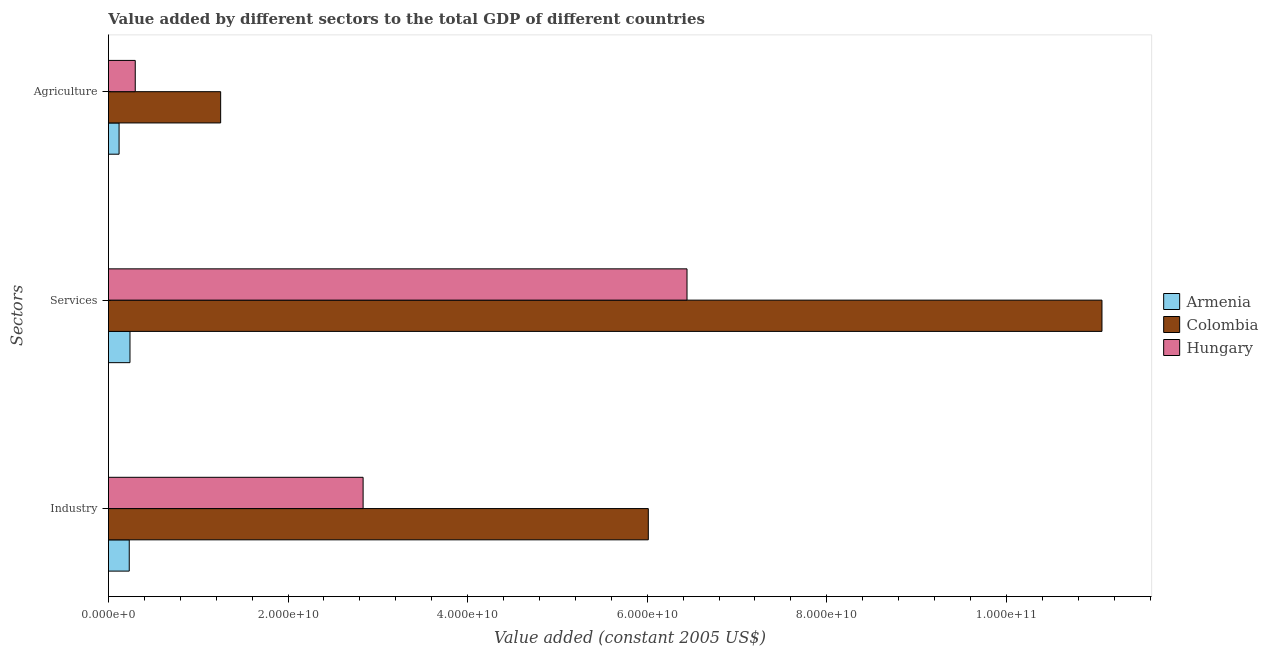Are the number of bars per tick equal to the number of legend labels?
Your answer should be compact. Yes. How many bars are there on the 1st tick from the top?
Offer a terse response. 3. How many bars are there on the 3rd tick from the bottom?
Your answer should be compact. 3. What is the label of the 3rd group of bars from the top?
Provide a succinct answer. Industry. What is the value added by services in Hungary?
Provide a short and direct response. 6.44e+1. Across all countries, what is the maximum value added by industrial sector?
Give a very brief answer. 6.01e+1. Across all countries, what is the minimum value added by industrial sector?
Give a very brief answer. 2.32e+09. In which country was the value added by industrial sector minimum?
Give a very brief answer. Armenia. What is the total value added by industrial sector in the graph?
Offer a terse response. 9.08e+1. What is the difference between the value added by agricultural sector in Armenia and that in Hungary?
Your answer should be compact. -1.80e+09. What is the difference between the value added by industrial sector in Hungary and the value added by services in Armenia?
Keep it short and to the point. 2.60e+1. What is the average value added by agricultural sector per country?
Your answer should be compact. 5.56e+09. What is the difference between the value added by industrial sector and value added by services in Colombia?
Offer a terse response. -5.05e+1. In how many countries, is the value added by agricultural sector greater than 32000000000 US$?
Give a very brief answer. 0. What is the ratio of the value added by agricultural sector in Colombia to that in Hungary?
Offer a terse response. 4.18. Is the value added by industrial sector in Armenia less than that in Hungary?
Offer a terse response. Yes. What is the difference between the highest and the second highest value added by agricultural sector?
Provide a succinct answer. 9.51e+09. What is the difference between the highest and the lowest value added by agricultural sector?
Offer a very short reply. 1.13e+1. Is the sum of the value added by industrial sector in Hungary and Colombia greater than the maximum value added by services across all countries?
Make the answer very short. No. What does the 3rd bar from the top in Industry represents?
Keep it short and to the point. Armenia. Is it the case that in every country, the sum of the value added by industrial sector and value added by services is greater than the value added by agricultural sector?
Your response must be concise. Yes. How many bars are there?
Your answer should be compact. 9. How many countries are there in the graph?
Your response must be concise. 3. What is the difference between two consecutive major ticks on the X-axis?
Provide a succinct answer. 2.00e+1. Are the values on the major ticks of X-axis written in scientific E-notation?
Your answer should be very brief. Yes. Does the graph contain any zero values?
Give a very brief answer. No. Where does the legend appear in the graph?
Keep it short and to the point. Center right. How are the legend labels stacked?
Your answer should be compact. Vertical. What is the title of the graph?
Your answer should be compact. Value added by different sectors to the total GDP of different countries. Does "Syrian Arab Republic" appear as one of the legend labels in the graph?
Your answer should be very brief. No. What is the label or title of the X-axis?
Your response must be concise. Value added (constant 2005 US$). What is the label or title of the Y-axis?
Ensure brevity in your answer.  Sectors. What is the Value added (constant 2005 US$) of Armenia in Industry?
Give a very brief answer. 2.32e+09. What is the Value added (constant 2005 US$) in Colombia in Industry?
Offer a very short reply. 6.01e+1. What is the Value added (constant 2005 US$) in Hungary in Industry?
Your response must be concise. 2.84e+1. What is the Value added (constant 2005 US$) in Armenia in Services?
Offer a very short reply. 2.40e+09. What is the Value added (constant 2005 US$) of Colombia in Services?
Ensure brevity in your answer.  1.11e+11. What is the Value added (constant 2005 US$) of Hungary in Services?
Offer a terse response. 6.44e+1. What is the Value added (constant 2005 US$) of Armenia in Agriculture?
Your response must be concise. 1.19e+09. What is the Value added (constant 2005 US$) in Colombia in Agriculture?
Ensure brevity in your answer.  1.25e+1. What is the Value added (constant 2005 US$) of Hungary in Agriculture?
Provide a short and direct response. 2.99e+09. Across all Sectors, what is the maximum Value added (constant 2005 US$) in Armenia?
Make the answer very short. 2.40e+09. Across all Sectors, what is the maximum Value added (constant 2005 US$) of Colombia?
Ensure brevity in your answer.  1.11e+11. Across all Sectors, what is the maximum Value added (constant 2005 US$) in Hungary?
Offer a terse response. 6.44e+1. Across all Sectors, what is the minimum Value added (constant 2005 US$) of Armenia?
Your response must be concise. 1.19e+09. Across all Sectors, what is the minimum Value added (constant 2005 US$) of Colombia?
Your answer should be very brief. 1.25e+1. Across all Sectors, what is the minimum Value added (constant 2005 US$) in Hungary?
Ensure brevity in your answer.  2.99e+09. What is the total Value added (constant 2005 US$) of Armenia in the graph?
Keep it short and to the point. 5.90e+09. What is the total Value added (constant 2005 US$) of Colombia in the graph?
Make the answer very short. 1.83e+11. What is the total Value added (constant 2005 US$) in Hungary in the graph?
Provide a succinct answer. 9.58e+1. What is the difference between the Value added (constant 2005 US$) in Armenia in Industry and that in Services?
Provide a short and direct response. -8.13e+07. What is the difference between the Value added (constant 2005 US$) in Colombia in Industry and that in Services?
Your answer should be very brief. -5.05e+1. What is the difference between the Value added (constant 2005 US$) of Hungary in Industry and that in Services?
Provide a succinct answer. -3.61e+1. What is the difference between the Value added (constant 2005 US$) in Armenia in Industry and that in Agriculture?
Your answer should be very brief. 1.13e+09. What is the difference between the Value added (constant 2005 US$) of Colombia in Industry and that in Agriculture?
Provide a short and direct response. 4.76e+1. What is the difference between the Value added (constant 2005 US$) in Hungary in Industry and that in Agriculture?
Your answer should be compact. 2.54e+1. What is the difference between the Value added (constant 2005 US$) of Armenia in Services and that in Agriculture?
Make the answer very short. 1.21e+09. What is the difference between the Value added (constant 2005 US$) of Colombia in Services and that in Agriculture?
Your answer should be very brief. 9.81e+1. What is the difference between the Value added (constant 2005 US$) of Hungary in Services and that in Agriculture?
Keep it short and to the point. 6.14e+1. What is the difference between the Value added (constant 2005 US$) in Armenia in Industry and the Value added (constant 2005 US$) in Colombia in Services?
Ensure brevity in your answer.  -1.08e+11. What is the difference between the Value added (constant 2005 US$) of Armenia in Industry and the Value added (constant 2005 US$) of Hungary in Services?
Your answer should be compact. -6.21e+1. What is the difference between the Value added (constant 2005 US$) in Colombia in Industry and the Value added (constant 2005 US$) in Hungary in Services?
Keep it short and to the point. -4.31e+09. What is the difference between the Value added (constant 2005 US$) of Armenia in Industry and the Value added (constant 2005 US$) of Colombia in Agriculture?
Ensure brevity in your answer.  -1.02e+1. What is the difference between the Value added (constant 2005 US$) in Armenia in Industry and the Value added (constant 2005 US$) in Hungary in Agriculture?
Offer a terse response. -6.68e+08. What is the difference between the Value added (constant 2005 US$) of Colombia in Industry and the Value added (constant 2005 US$) of Hungary in Agriculture?
Make the answer very short. 5.71e+1. What is the difference between the Value added (constant 2005 US$) of Armenia in Services and the Value added (constant 2005 US$) of Colombia in Agriculture?
Give a very brief answer. -1.01e+1. What is the difference between the Value added (constant 2005 US$) in Armenia in Services and the Value added (constant 2005 US$) in Hungary in Agriculture?
Offer a terse response. -5.87e+08. What is the difference between the Value added (constant 2005 US$) in Colombia in Services and the Value added (constant 2005 US$) in Hungary in Agriculture?
Offer a terse response. 1.08e+11. What is the average Value added (constant 2005 US$) in Armenia per Sectors?
Your answer should be compact. 1.97e+09. What is the average Value added (constant 2005 US$) of Colombia per Sectors?
Make the answer very short. 6.11e+1. What is the average Value added (constant 2005 US$) of Hungary per Sectors?
Keep it short and to the point. 3.19e+1. What is the difference between the Value added (constant 2005 US$) in Armenia and Value added (constant 2005 US$) in Colombia in Industry?
Give a very brief answer. -5.78e+1. What is the difference between the Value added (constant 2005 US$) in Armenia and Value added (constant 2005 US$) in Hungary in Industry?
Ensure brevity in your answer.  -2.60e+1. What is the difference between the Value added (constant 2005 US$) of Colombia and Value added (constant 2005 US$) of Hungary in Industry?
Ensure brevity in your answer.  3.18e+1. What is the difference between the Value added (constant 2005 US$) in Armenia and Value added (constant 2005 US$) in Colombia in Services?
Your answer should be very brief. -1.08e+11. What is the difference between the Value added (constant 2005 US$) of Armenia and Value added (constant 2005 US$) of Hungary in Services?
Make the answer very short. -6.20e+1. What is the difference between the Value added (constant 2005 US$) of Colombia and Value added (constant 2005 US$) of Hungary in Services?
Your answer should be compact. 4.62e+1. What is the difference between the Value added (constant 2005 US$) in Armenia and Value added (constant 2005 US$) in Colombia in Agriculture?
Offer a terse response. -1.13e+1. What is the difference between the Value added (constant 2005 US$) of Armenia and Value added (constant 2005 US$) of Hungary in Agriculture?
Your answer should be compact. -1.80e+09. What is the difference between the Value added (constant 2005 US$) of Colombia and Value added (constant 2005 US$) of Hungary in Agriculture?
Give a very brief answer. 9.51e+09. What is the ratio of the Value added (constant 2005 US$) of Armenia in Industry to that in Services?
Provide a short and direct response. 0.97. What is the ratio of the Value added (constant 2005 US$) of Colombia in Industry to that in Services?
Provide a short and direct response. 0.54. What is the ratio of the Value added (constant 2005 US$) of Hungary in Industry to that in Services?
Give a very brief answer. 0.44. What is the ratio of the Value added (constant 2005 US$) in Armenia in Industry to that in Agriculture?
Ensure brevity in your answer.  1.95. What is the ratio of the Value added (constant 2005 US$) in Colombia in Industry to that in Agriculture?
Offer a very short reply. 4.81. What is the ratio of the Value added (constant 2005 US$) in Hungary in Industry to that in Agriculture?
Give a very brief answer. 9.5. What is the ratio of the Value added (constant 2005 US$) of Armenia in Services to that in Agriculture?
Provide a succinct answer. 2.02. What is the ratio of the Value added (constant 2005 US$) in Colombia in Services to that in Agriculture?
Offer a terse response. 8.85. What is the ratio of the Value added (constant 2005 US$) in Hungary in Services to that in Agriculture?
Ensure brevity in your answer.  21.57. What is the difference between the highest and the second highest Value added (constant 2005 US$) of Armenia?
Make the answer very short. 8.13e+07. What is the difference between the highest and the second highest Value added (constant 2005 US$) of Colombia?
Offer a very short reply. 5.05e+1. What is the difference between the highest and the second highest Value added (constant 2005 US$) of Hungary?
Provide a succinct answer. 3.61e+1. What is the difference between the highest and the lowest Value added (constant 2005 US$) in Armenia?
Provide a succinct answer. 1.21e+09. What is the difference between the highest and the lowest Value added (constant 2005 US$) in Colombia?
Your answer should be very brief. 9.81e+1. What is the difference between the highest and the lowest Value added (constant 2005 US$) in Hungary?
Make the answer very short. 6.14e+1. 